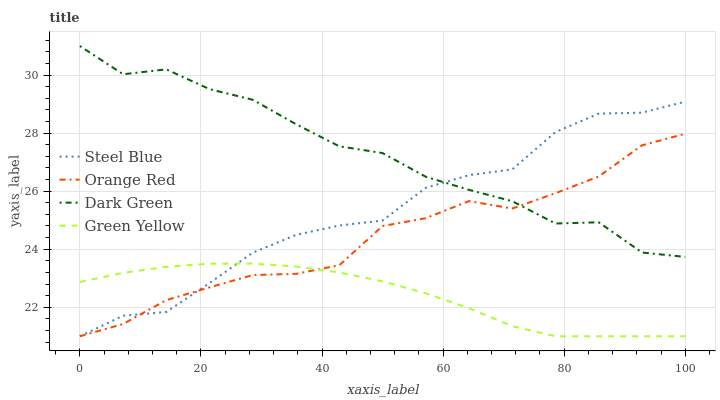Does Green Yellow have the minimum area under the curve?
Answer yes or no. Yes. Does Dark Green have the maximum area under the curve?
Answer yes or no. Yes. Does Steel Blue have the minimum area under the curve?
Answer yes or no. No. Does Steel Blue have the maximum area under the curve?
Answer yes or no. No. Is Green Yellow the smoothest?
Answer yes or no. Yes. Is Dark Green the roughest?
Answer yes or no. Yes. Is Steel Blue the smoothest?
Answer yes or no. No. Is Steel Blue the roughest?
Answer yes or no. No. Does Green Yellow have the lowest value?
Answer yes or no. Yes. Does Dark Green have the lowest value?
Answer yes or no. No. Does Dark Green have the highest value?
Answer yes or no. Yes. Does Steel Blue have the highest value?
Answer yes or no. No. Is Green Yellow less than Dark Green?
Answer yes or no. Yes. Is Dark Green greater than Green Yellow?
Answer yes or no. Yes. Does Orange Red intersect Green Yellow?
Answer yes or no. Yes. Is Orange Red less than Green Yellow?
Answer yes or no. No. Is Orange Red greater than Green Yellow?
Answer yes or no. No. Does Green Yellow intersect Dark Green?
Answer yes or no. No. 